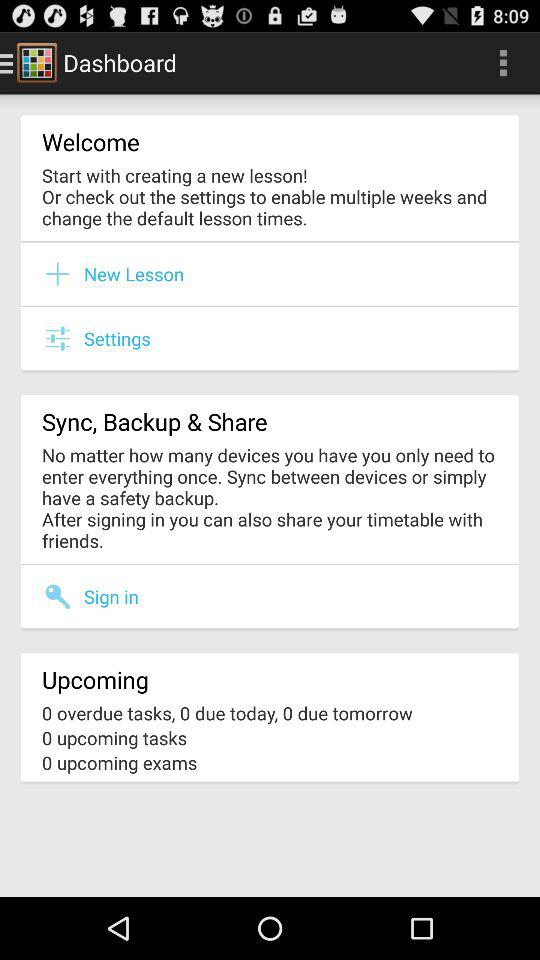What is the number of overdue tasks? The number of overdue tasks is zero. 